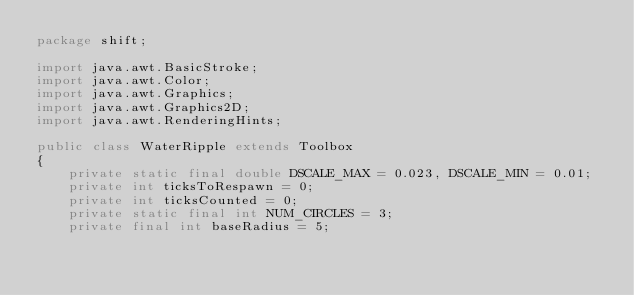<code> <loc_0><loc_0><loc_500><loc_500><_Java_>package shift;

import java.awt.BasicStroke;
import java.awt.Color;
import java.awt.Graphics;
import java.awt.Graphics2D;
import java.awt.RenderingHints;

public class WaterRipple extends Toolbox
{
    private static final double DSCALE_MAX = 0.023, DSCALE_MIN = 0.01;
    private int ticksToRespawn = 0;
    private int ticksCounted = 0;
    private static final int NUM_CIRCLES = 3;
    private final int baseRadius = 5;</code> 